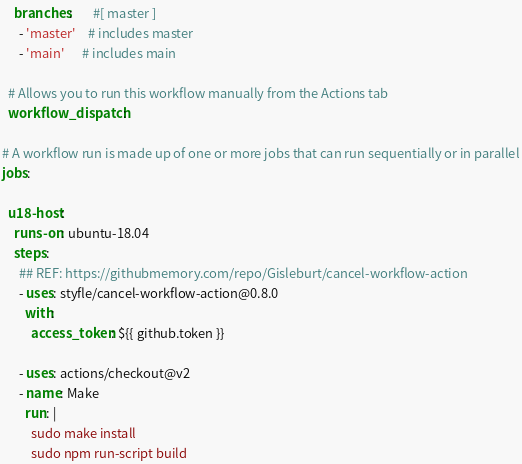<code> <loc_0><loc_0><loc_500><loc_500><_YAML_>    branches:       #[ master ]
      - 'master'    # includes master
      - 'main'      # includes main

  # Allows you to run this workflow manually from the Actions tab
  workflow_dispatch:

# A workflow run is made up of one or more jobs that can run sequentially or in parallel
jobs:

  u18-host:
    runs-on: ubuntu-18.04
    steps:
      ## REF: https://githubmemory.com/repo/Gisleburt/cancel-workflow-action
      - uses: styfle/cancel-workflow-action@0.8.0
        with:
          access_token: ${{ github.token }}

      - uses: actions/checkout@v2
      - name: Make
        run: |
          sudo make install
          sudo npm run-script build</code> 